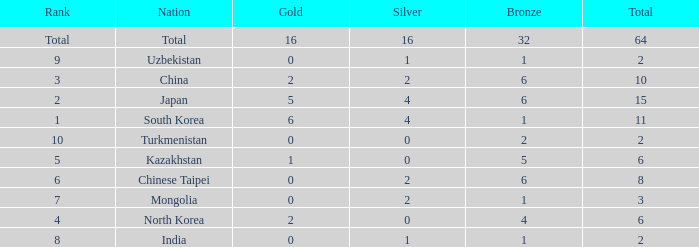What's the biggest Bronze that has less than 0 Silvers? None. 